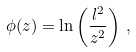<formula> <loc_0><loc_0><loc_500><loc_500>\phi ( z ) = \ln \left ( \frac { l ^ { 2 } } { z ^ { 2 } } \right ) \, ,</formula> 